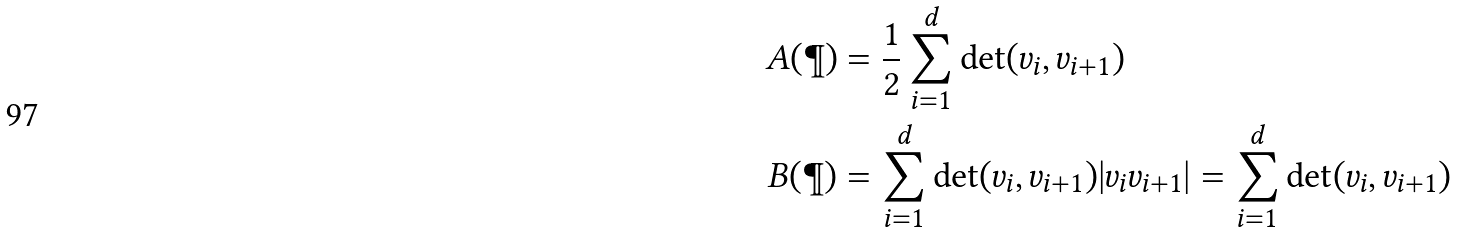Convert formula to latex. <formula><loc_0><loc_0><loc_500><loc_500>A ( \P ) & = \frac { 1 } { 2 } \sum _ { i = 1 } ^ { d } \det ( v _ { i } , v _ { i + 1 } ) \\ B ( \P ) & = \sum _ { i = 1 } ^ { d } \det ( v _ { i } , v _ { i + 1 } ) | v _ { i } v _ { i + 1 } | = \sum _ { i = 1 } ^ { d } \det ( v _ { i } , v _ { i + 1 } )</formula> 